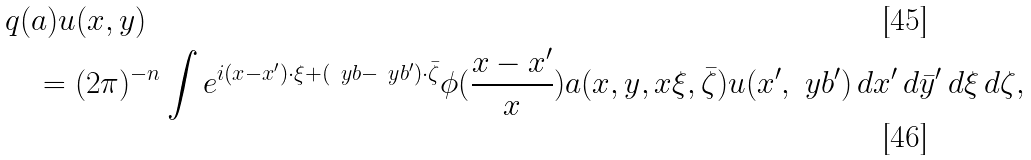Convert formula to latex. <formula><loc_0><loc_0><loc_500><loc_500>& q ( a ) u ( x , y ) \\ & \quad = ( 2 \pi ) ^ { - n } \int e ^ { i ( x - x ^ { \prime } ) \cdot \xi + ( \ y b - \ y b ^ { \prime } ) \cdot \bar { \zeta } } \phi ( \frac { x - x ^ { \prime } } { x } ) a ( x , y , x \xi , \bar { \zeta } ) u ( x ^ { \prime } , \ y b ^ { \prime } ) \, d x ^ { \prime } \, d \bar { y } ^ { \prime } \, d \xi \, d \zeta ,</formula> 